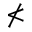<formula> <loc_0><loc_0><loc_500><loc_500>\nless</formula> 